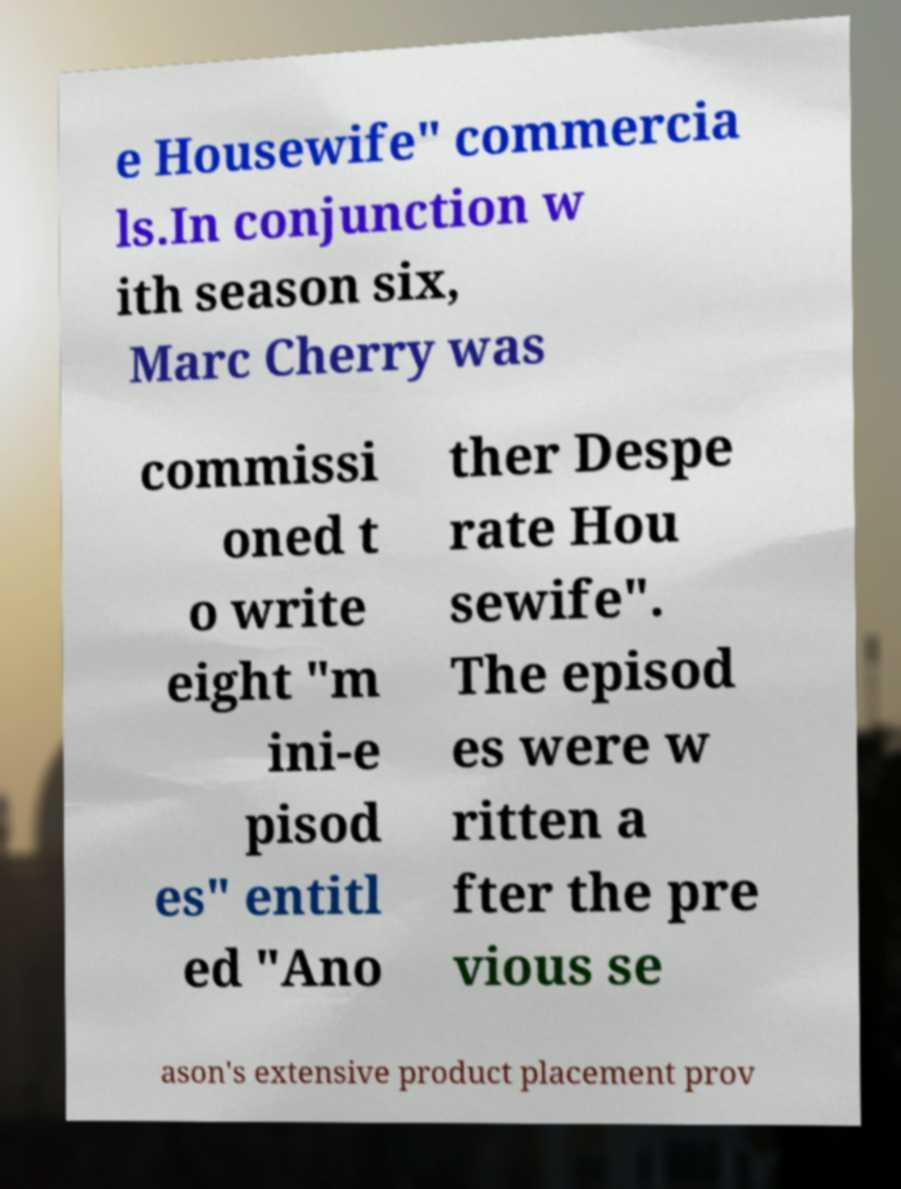Please identify and transcribe the text found in this image. e Housewife" commercia ls.In conjunction w ith season six, Marc Cherry was commissi oned t o write eight "m ini-e pisod es" entitl ed "Ano ther Despe rate Hou sewife". The episod es were w ritten a fter the pre vious se ason's extensive product placement prov 